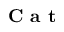<formula> <loc_0><loc_0><loc_500><loc_500>C a t</formula> 